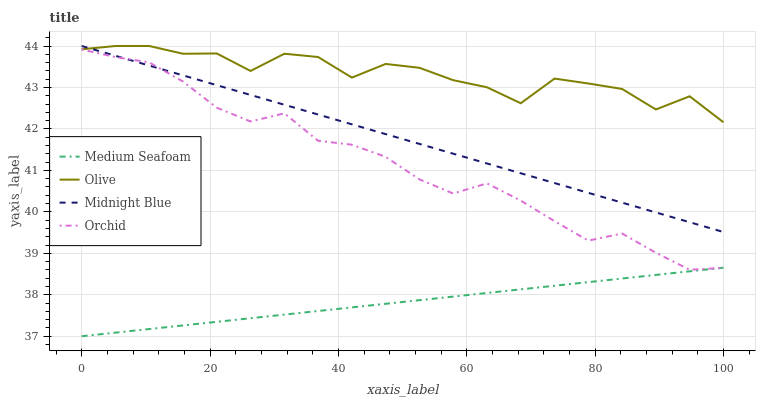Does Medium Seafoam have the minimum area under the curve?
Answer yes or no. Yes. Does Olive have the maximum area under the curve?
Answer yes or no. Yes. Does Orchid have the minimum area under the curve?
Answer yes or no. No. Does Orchid have the maximum area under the curve?
Answer yes or no. No. Is Midnight Blue the smoothest?
Answer yes or no. Yes. Is Olive the roughest?
Answer yes or no. Yes. Is Orchid the smoothest?
Answer yes or no. No. Is Orchid the roughest?
Answer yes or no. No. Does Orchid have the lowest value?
Answer yes or no. No. Does Midnight Blue have the highest value?
Answer yes or no. Yes. Does Orchid have the highest value?
Answer yes or no. No. Is Orchid less than Olive?
Answer yes or no. Yes. Is Olive greater than Medium Seafoam?
Answer yes or no. Yes. Does Midnight Blue intersect Olive?
Answer yes or no. Yes. Is Midnight Blue less than Olive?
Answer yes or no. No. Is Midnight Blue greater than Olive?
Answer yes or no. No. Does Orchid intersect Olive?
Answer yes or no. No. 